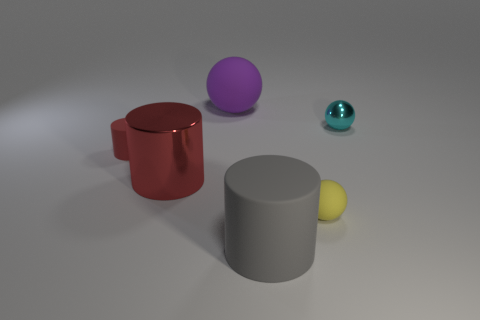Subtract all small cyan shiny spheres. How many spheres are left? 2 Subtract all purple spheres. How many spheres are left? 2 Subtract all green spheres. How many red cylinders are left? 2 Subtract all tiny yellow objects. Subtract all large gray objects. How many objects are left? 4 Add 3 rubber spheres. How many rubber spheres are left? 5 Add 4 matte objects. How many matte objects exist? 8 Add 3 small yellow rubber objects. How many objects exist? 9 Subtract 0 purple cylinders. How many objects are left? 6 Subtract 1 cylinders. How many cylinders are left? 2 Subtract all cyan cylinders. Subtract all cyan spheres. How many cylinders are left? 3 